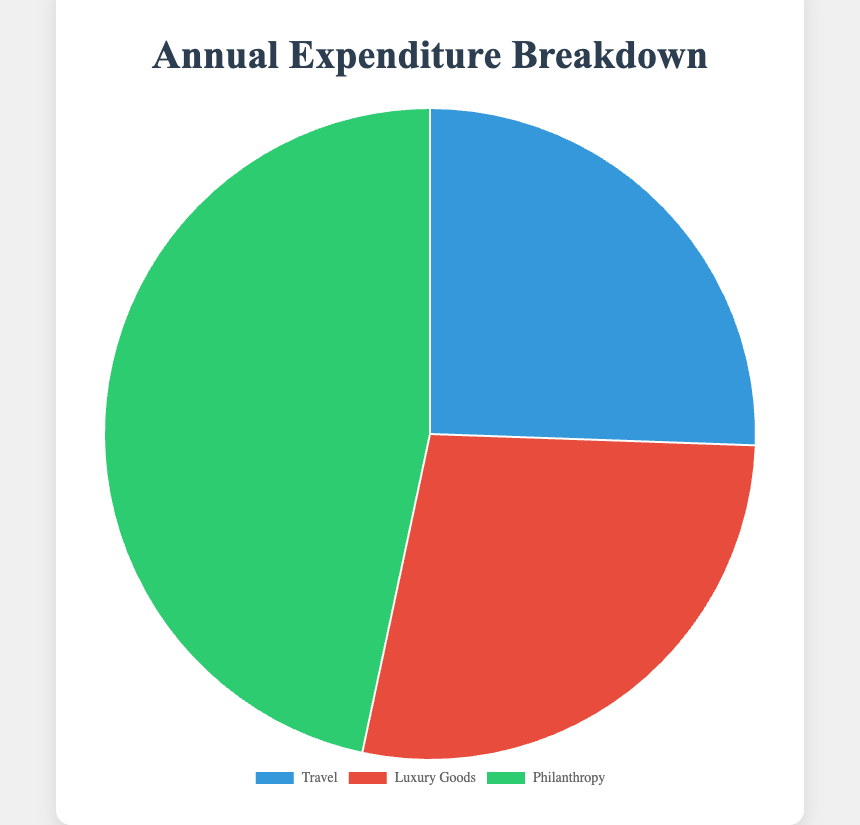What is the total expenditure on Travel? The three categories under Travel are Private Jet Charters, Luxury Vacation Packages, and 5-Star Hotel Stays. Sum these values: $1,500,000 + $500,000 + $300,000. The total is $2,300,000.
Answer: $2,300,000 What percentage of the total expenditure is on Philanthropy? The Philanthropy expenditure amounts to $4,200,000 out of a total expenditure of $9,000,000 (sum of all expenditures). The percentage is calculated as ($4,200,000 / $9,000,000) * 100.
Answer: 47% Which expenditure category has the highest total amount? By examining the total amounts on the pie chart, Philanthropy has the highest total at $4,200,000.
Answer: Philanthropy Compare the expenditure between Luxury Goods and Travel. Which is higher and by how much? Total expenditure on Luxury Goods is $2,500,000 and on Travel is $2,300,000. The difference is $2,500,000 - $2,300,000.
Answer: Luxury Goods by $200,000 What is the visual representation color for Travel in the pie chart? The Travel segment on the pie chart is colored blue.
Answer: Blue If you combine the expenditure on Luxury Cars and Private Jet Charters, how does this compare to the total expenditure on Philanthropy? Luxury Cars ($1,200,000) + Private Jet Charters ($1,500,000) equals $2,700,000. Compared to Philanthropy ($4,200,000).
Answer: Philanthropy is $1,500,000 more Which visual section appears largest on the pie chart, and why? The Philanthropy section appears largest on the pie chart because it represents the highest total amount of $4,200,000.
Answer: Philanthropy Is the expenditure on High-End Fashion more or less than the expenditure on Luxury Vacation Packages? High-End Fashion expenditure is $750,000, which is more than Luxury Vacation Packages at $500,000.
Answer: More 